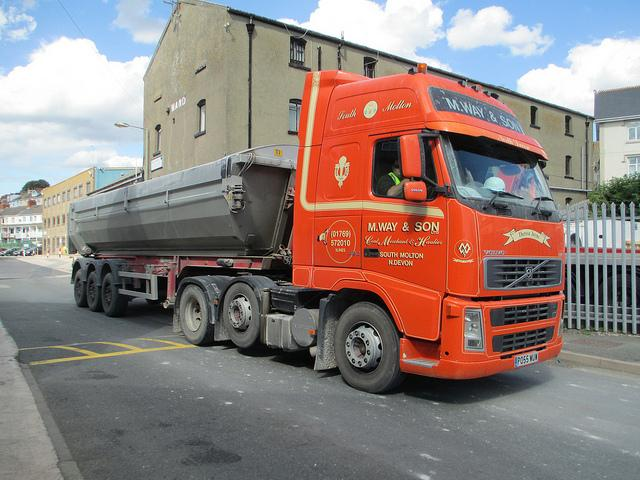What business park does this company operate out of?

Choices:
A) pathfields
B) safeways
C) journeyman
D) legacy pathfields 